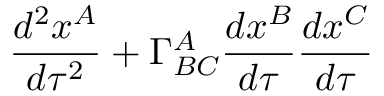<formula> <loc_0><loc_0><loc_500><loc_500>\frac { d ^ { 2 } x ^ { A } } { d \tau ^ { 2 } } + \Gamma _ { B C } ^ { A } \frac { d x ^ { B } } { d \tau } \frac { d x ^ { C } } { d \tau }</formula> 